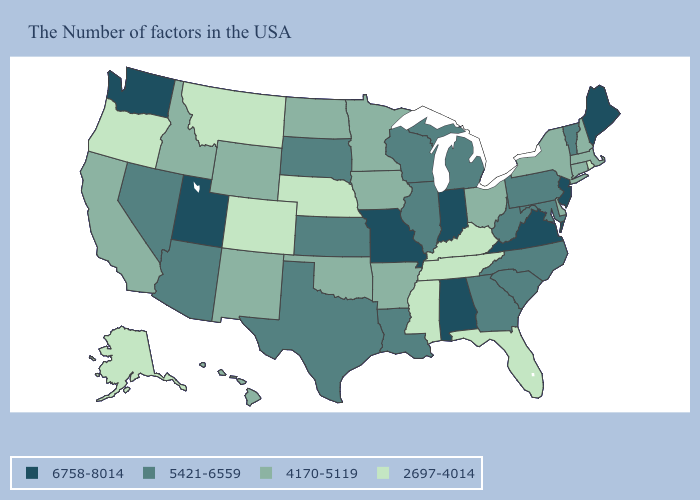Which states have the lowest value in the Northeast?
Short answer required. Rhode Island. Name the states that have a value in the range 4170-5119?
Keep it brief. Massachusetts, New Hampshire, Connecticut, New York, Delaware, Ohio, Arkansas, Minnesota, Iowa, Oklahoma, North Dakota, Wyoming, New Mexico, Idaho, California, Hawaii. What is the lowest value in the USA?
Keep it brief. 2697-4014. Among the states that border North Dakota , which have the highest value?
Quick response, please. South Dakota. Name the states that have a value in the range 5421-6559?
Be succinct. Vermont, Maryland, Pennsylvania, North Carolina, South Carolina, West Virginia, Georgia, Michigan, Wisconsin, Illinois, Louisiana, Kansas, Texas, South Dakota, Arizona, Nevada. Name the states that have a value in the range 4170-5119?
Write a very short answer. Massachusetts, New Hampshire, Connecticut, New York, Delaware, Ohio, Arkansas, Minnesota, Iowa, Oklahoma, North Dakota, Wyoming, New Mexico, Idaho, California, Hawaii. What is the value of Wisconsin?
Short answer required. 5421-6559. Name the states that have a value in the range 4170-5119?
Keep it brief. Massachusetts, New Hampshire, Connecticut, New York, Delaware, Ohio, Arkansas, Minnesota, Iowa, Oklahoma, North Dakota, Wyoming, New Mexico, Idaho, California, Hawaii. Name the states that have a value in the range 6758-8014?
Keep it brief. Maine, New Jersey, Virginia, Indiana, Alabama, Missouri, Utah, Washington. What is the value of Colorado?
Answer briefly. 2697-4014. What is the value of Missouri?
Keep it brief. 6758-8014. Does Wisconsin have the highest value in the MidWest?
Keep it brief. No. Does Maine have a higher value than Utah?
Short answer required. No. What is the lowest value in the Northeast?
Keep it brief. 2697-4014. Name the states that have a value in the range 4170-5119?
Quick response, please. Massachusetts, New Hampshire, Connecticut, New York, Delaware, Ohio, Arkansas, Minnesota, Iowa, Oklahoma, North Dakota, Wyoming, New Mexico, Idaho, California, Hawaii. 